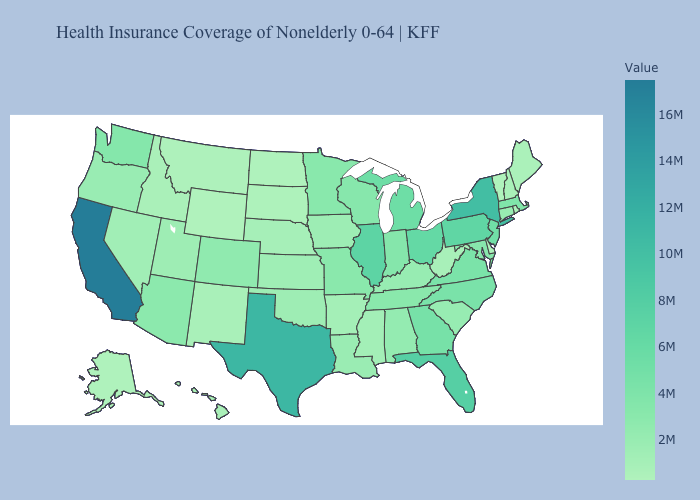Does Oregon have a lower value than Georgia?
Concise answer only. Yes. Does New Hampshire have the lowest value in the USA?
Short answer required. No. Does Wyoming have the lowest value in the West?
Keep it brief. Yes. Does South Dakota have the lowest value in the MidWest?
Concise answer only. No. Does Arkansas have the lowest value in the USA?
Short answer required. No. Is the legend a continuous bar?
Quick response, please. Yes. Among the states that border Utah , which have the highest value?
Answer briefly. Arizona. Among the states that border South Dakota , does Wyoming have the lowest value?
Short answer required. Yes. 